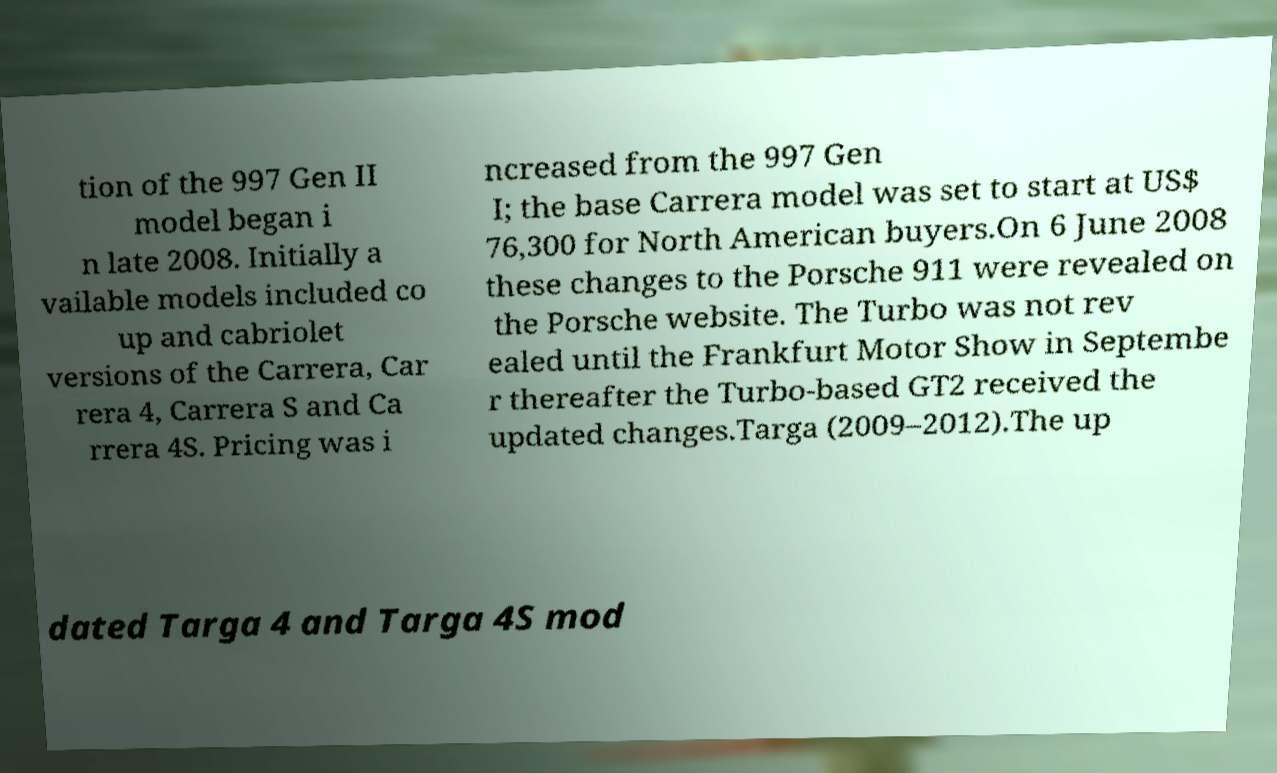Could you assist in decoding the text presented in this image and type it out clearly? tion of the 997 Gen II model began i n late 2008. Initially a vailable models included co up and cabriolet versions of the Carrera, Car rera 4, Carrera S and Ca rrera 4S. Pricing was i ncreased from the 997 Gen I; the base Carrera model was set to start at US$ 76,300 for North American buyers.On 6 June 2008 these changes to the Porsche 911 were revealed on the Porsche website. The Turbo was not rev ealed until the Frankfurt Motor Show in Septembe r thereafter the Turbo-based GT2 received the updated changes.Targa (2009–2012).The up dated Targa 4 and Targa 4S mod 